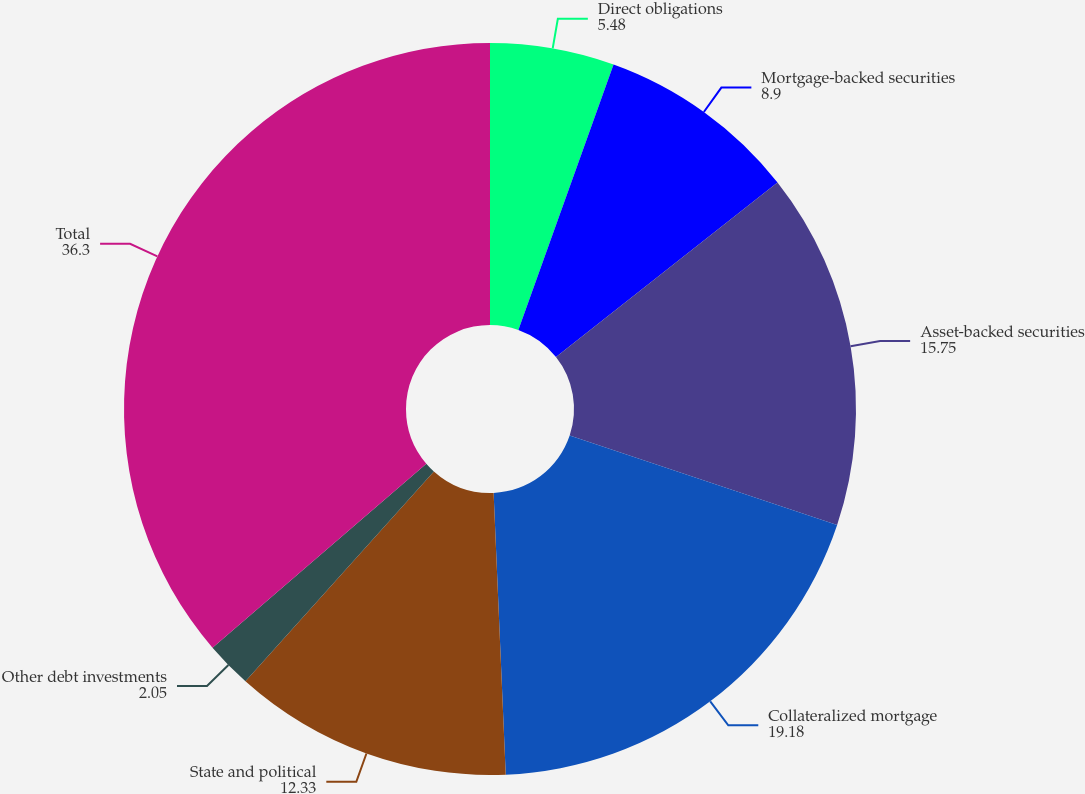<chart> <loc_0><loc_0><loc_500><loc_500><pie_chart><fcel>Direct obligations<fcel>Mortgage-backed securities<fcel>Asset-backed securities<fcel>Collateralized mortgage<fcel>State and political<fcel>Other debt investments<fcel>Total<nl><fcel>5.48%<fcel>8.9%<fcel>15.75%<fcel>19.18%<fcel>12.33%<fcel>2.05%<fcel>36.3%<nl></chart> 